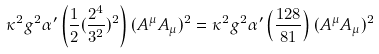<formula> <loc_0><loc_0><loc_500><loc_500>\kappa ^ { 2 } g ^ { 2 } \alpha ^ { \prime } \left ( \frac { 1 } { 2 } ( \frac { 2 ^ { 4 } } { 3 ^ { 2 } } ) ^ { 2 } \right ) ( A ^ { \mu } A _ { \mu } ) ^ { 2 } = \kappa ^ { 2 } g ^ { 2 } \alpha ^ { \prime } \left ( \frac { 1 2 8 } { 8 1 } \right ) ( A ^ { \mu } A _ { \mu } ) ^ { 2 }</formula> 